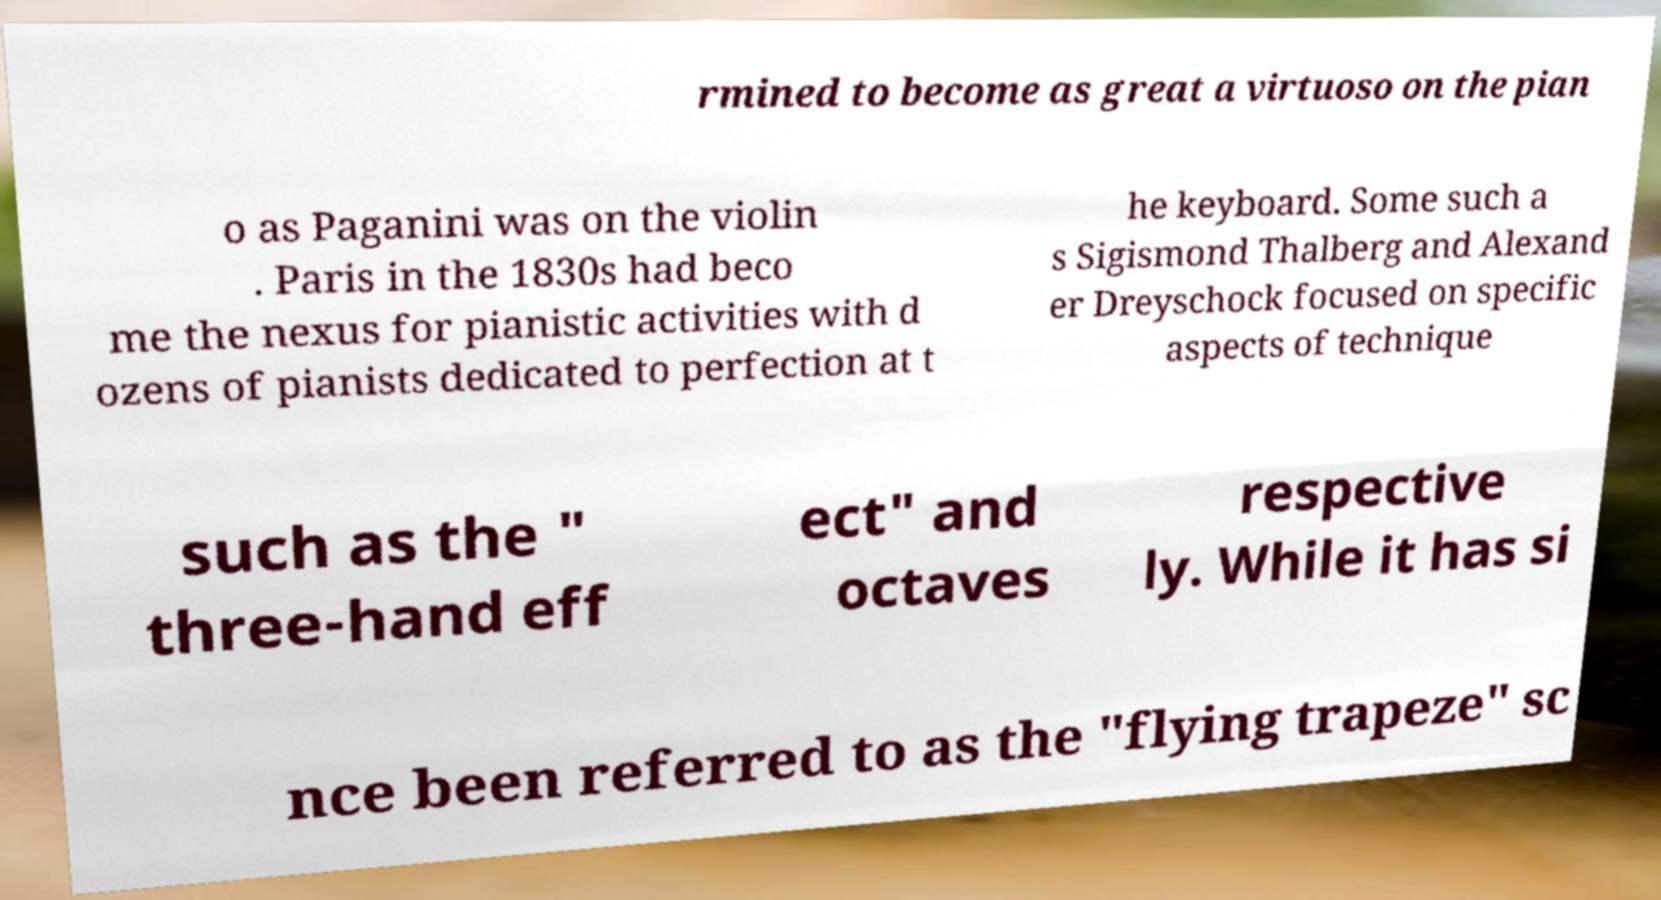Could you extract and type out the text from this image? rmined to become as great a virtuoso on the pian o as Paganini was on the violin . Paris in the 1830s had beco me the nexus for pianistic activities with d ozens of pianists dedicated to perfection at t he keyboard. Some such a s Sigismond Thalberg and Alexand er Dreyschock focused on specific aspects of technique such as the " three-hand eff ect" and octaves respective ly. While it has si nce been referred to as the "flying trapeze" sc 